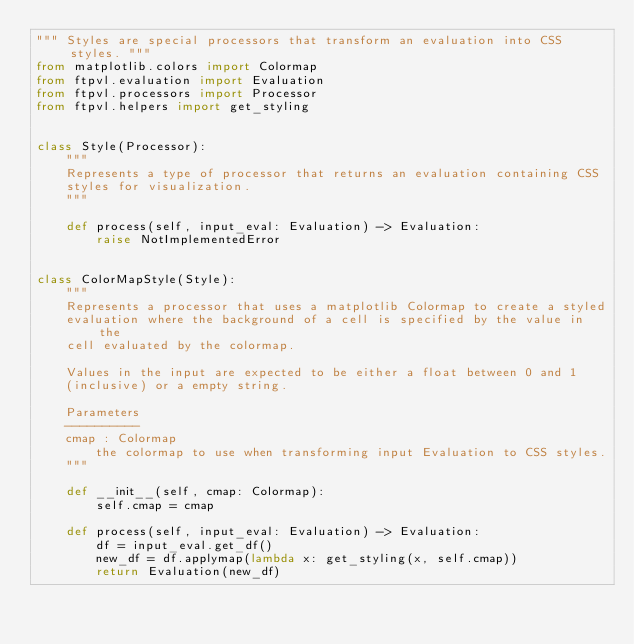Convert code to text. <code><loc_0><loc_0><loc_500><loc_500><_Python_>""" Styles are special processors that transform an evaluation into CSS styles. """
from matplotlib.colors import Colormap
from ftpvl.evaluation import Evaluation
from ftpvl.processors import Processor
from ftpvl.helpers import get_styling


class Style(Processor):
    """
    Represents a type of processor that returns an evaluation containing CSS
    styles for visualization.
    """

    def process(self, input_eval: Evaluation) -> Evaluation:
        raise NotImplementedError


class ColorMapStyle(Style):
    """
    Represents a processor that uses a matplotlib Colormap to create a styled
    evaluation where the background of a cell is specified by the value in the
    cell evaluated by the colormap.

    Values in the input are expected to be either a float between 0 and 1
    (inclusive) or a empty string.

    Parameters
    ----------
    cmap : Colormap
        the colormap to use when transforming input Evaluation to CSS styles.
    """

    def __init__(self, cmap: Colormap):
        self.cmap = cmap

    def process(self, input_eval: Evaluation) -> Evaluation:
        df = input_eval.get_df()
        new_df = df.applymap(lambda x: get_styling(x, self.cmap))
        return Evaluation(new_df)
</code> 